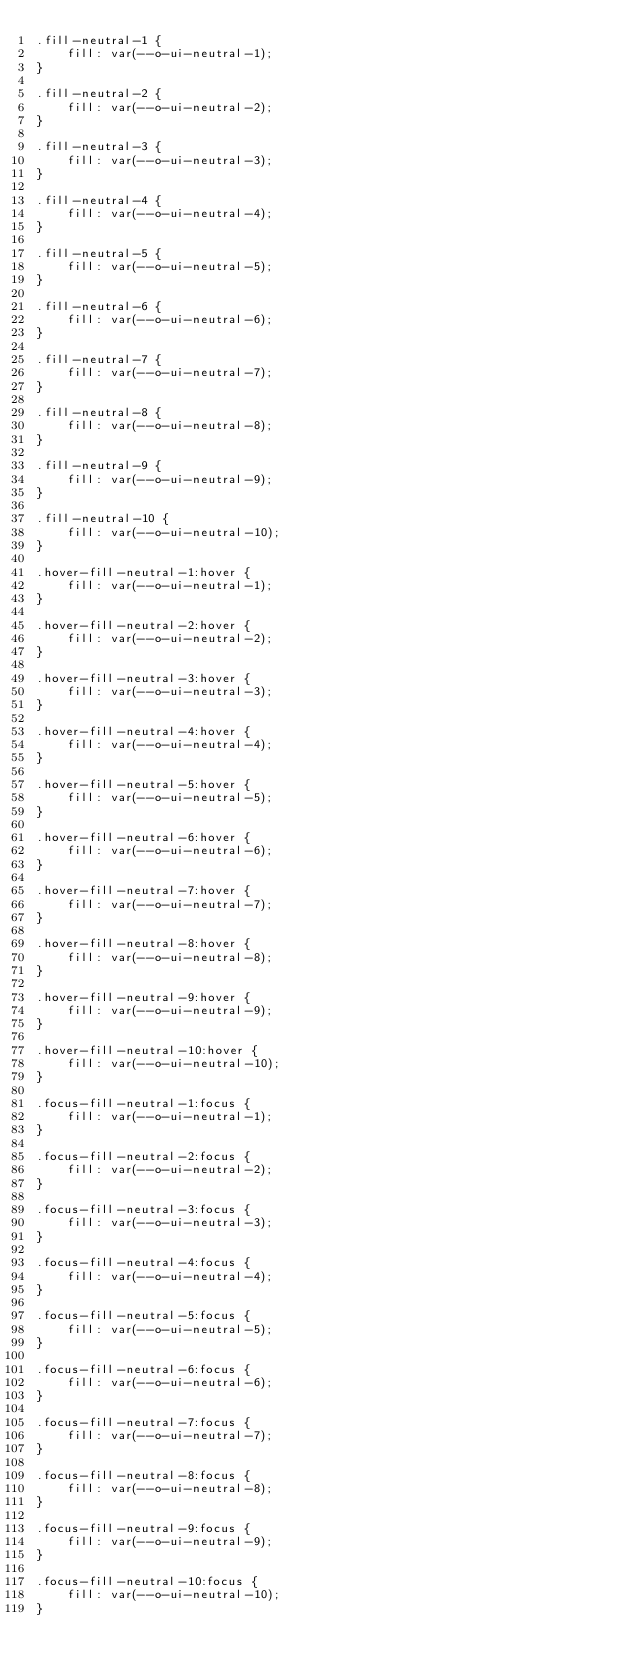Convert code to text. <code><loc_0><loc_0><loc_500><loc_500><_CSS_>.fill-neutral-1 {
    fill: var(--o-ui-neutral-1);
}

.fill-neutral-2 {
    fill: var(--o-ui-neutral-2);
}

.fill-neutral-3 {
    fill: var(--o-ui-neutral-3);
}

.fill-neutral-4 {
    fill: var(--o-ui-neutral-4);
}

.fill-neutral-5 {
    fill: var(--o-ui-neutral-5);
}

.fill-neutral-6 {
    fill: var(--o-ui-neutral-6);
}

.fill-neutral-7 {
    fill: var(--o-ui-neutral-7);
}

.fill-neutral-8 {
    fill: var(--o-ui-neutral-8);
}

.fill-neutral-9 {
    fill: var(--o-ui-neutral-9);
}

.fill-neutral-10 {
    fill: var(--o-ui-neutral-10);
}

.hover-fill-neutral-1:hover {
    fill: var(--o-ui-neutral-1);
}

.hover-fill-neutral-2:hover {
    fill: var(--o-ui-neutral-2);
}

.hover-fill-neutral-3:hover {
    fill: var(--o-ui-neutral-3);
}

.hover-fill-neutral-4:hover {
    fill: var(--o-ui-neutral-4);
}

.hover-fill-neutral-5:hover {
    fill: var(--o-ui-neutral-5);
}

.hover-fill-neutral-6:hover {
    fill: var(--o-ui-neutral-6);
}

.hover-fill-neutral-7:hover {
    fill: var(--o-ui-neutral-7);
}

.hover-fill-neutral-8:hover {
    fill: var(--o-ui-neutral-8);
}

.hover-fill-neutral-9:hover {
    fill: var(--o-ui-neutral-9);
}

.hover-fill-neutral-10:hover {
    fill: var(--o-ui-neutral-10);
}

.focus-fill-neutral-1:focus {
    fill: var(--o-ui-neutral-1);
}

.focus-fill-neutral-2:focus {
    fill: var(--o-ui-neutral-2);
}

.focus-fill-neutral-3:focus {
    fill: var(--o-ui-neutral-3);
}

.focus-fill-neutral-4:focus {
    fill: var(--o-ui-neutral-4);
}

.focus-fill-neutral-5:focus {
    fill: var(--o-ui-neutral-5);
}

.focus-fill-neutral-6:focus {
    fill: var(--o-ui-neutral-6);
}

.focus-fill-neutral-7:focus {
    fill: var(--o-ui-neutral-7);
}

.focus-fill-neutral-8:focus {
    fill: var(--o-ui-neutral-8);
}

.focus-fill-neutral-9:focus {
    fill: var(--o-ui-neutral-9);
}

.focus-fill-neutral-10:focus {
    fill: var(--o-ui-neutral-10);
}
</code> 